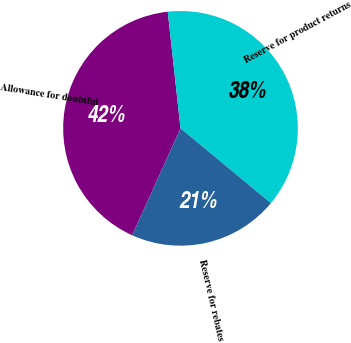Convert chart to OTSL. <chart><loc_0><loc_0><loc_500><loc_500><pie_chart><fcel>Allowance for doubtful<fcel>Reserve for product returns<fcel>Reserve for rebates<nl><fcel>41.51%<fcel>37.74%<fcel>20.75%<nl></chart> 